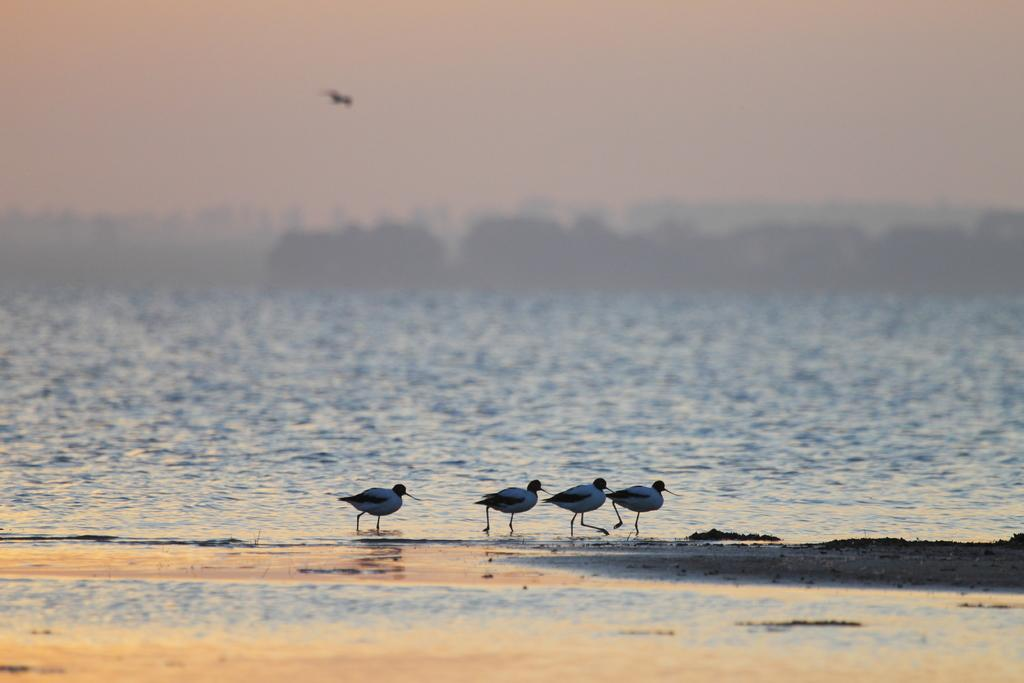What type of animals can be seen in the image? Birds can be seen in the image. What is the primary element in which the birds are situated? The birds are situated in water. What part of the natural environment is visible in the image? The sky is visible in the image. What type of music can be heard coming from the birds in the image? There is no indication in the image that the birds are making any sounds, let alone music. 